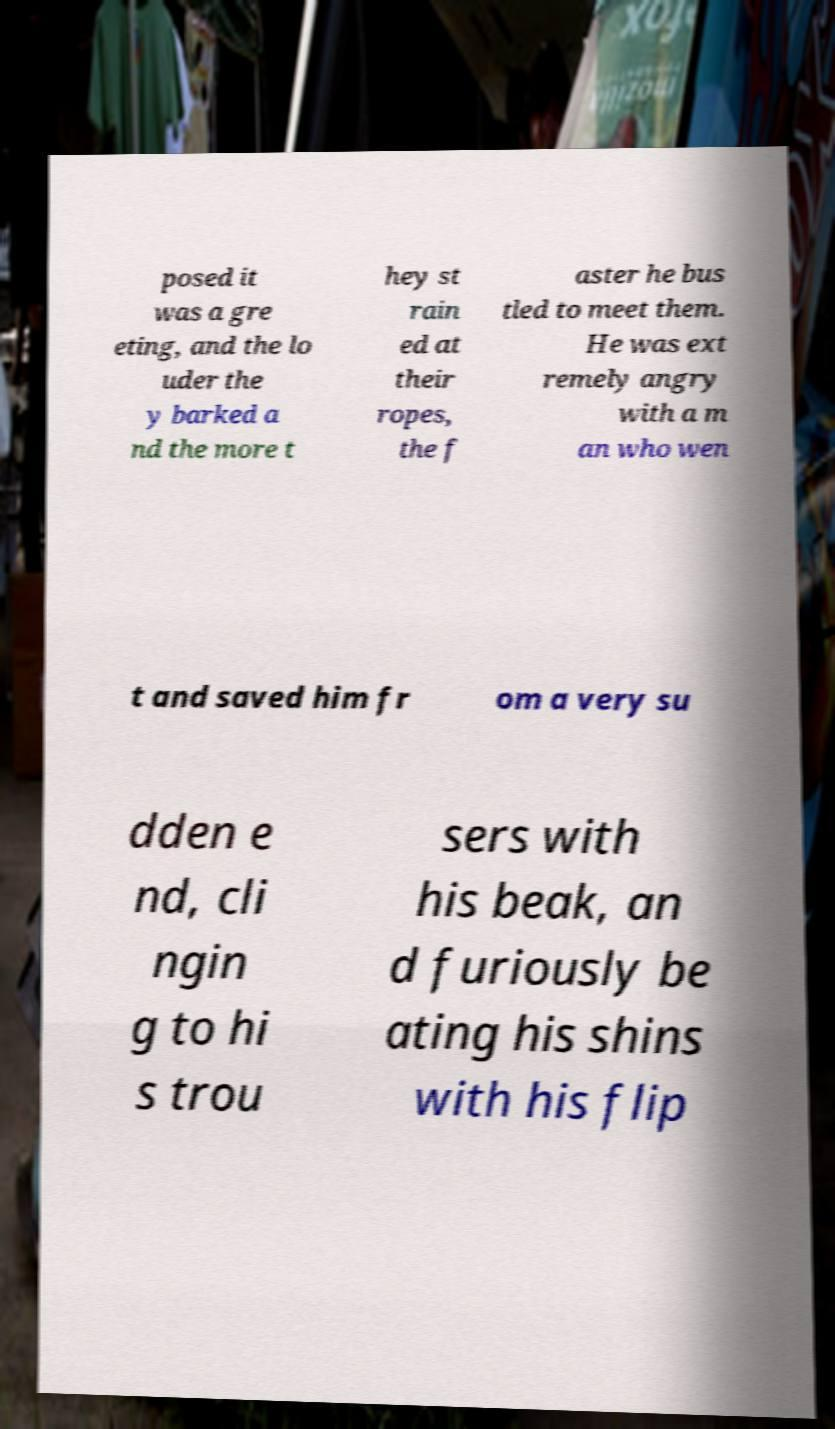Please identify and transcribe the text found in this image. posed it was a gre eting, and the lo uder the y barked a nd the more t hey st rain ed at their ropes, the f aster he bus tled to meet them. He was ext remely angry with a m an who wen t and saved him fr om a very su dden e nd, cli ngin g to hi s trou sers with his beak, an d furiously be ating his shins with his flip 